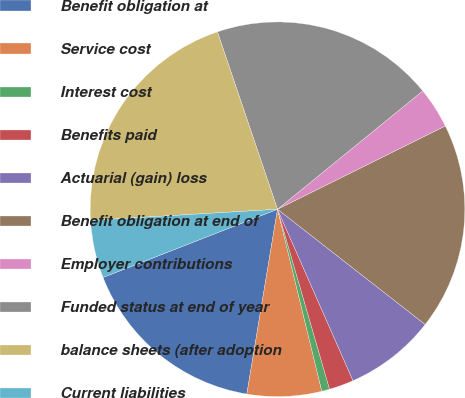Convert chart. <chart><loc_0><loc_0><loc_500><loc_500><pie_chart><fcel>Benefit obligation at<fcel>Service cost<fcel>Interest cost<fcel>Benefits paid<fcel>Actuarial (gain) loss<fcel>Benefit obligation at end of<fcel>Employer contributions<fcel>Funded status at end of year<fcel>balance sheets (after adoption<fcel>Current liabilities<nl><fcel>16.45%<fcel>6.42%<fcel>0.68%<fcel>2.12%<fcel>7.85%<fcel>17.88%<fcel>3.55%<fcel>19.32%<fcel>20.75%<fcel>4.98%<nl></chart> 